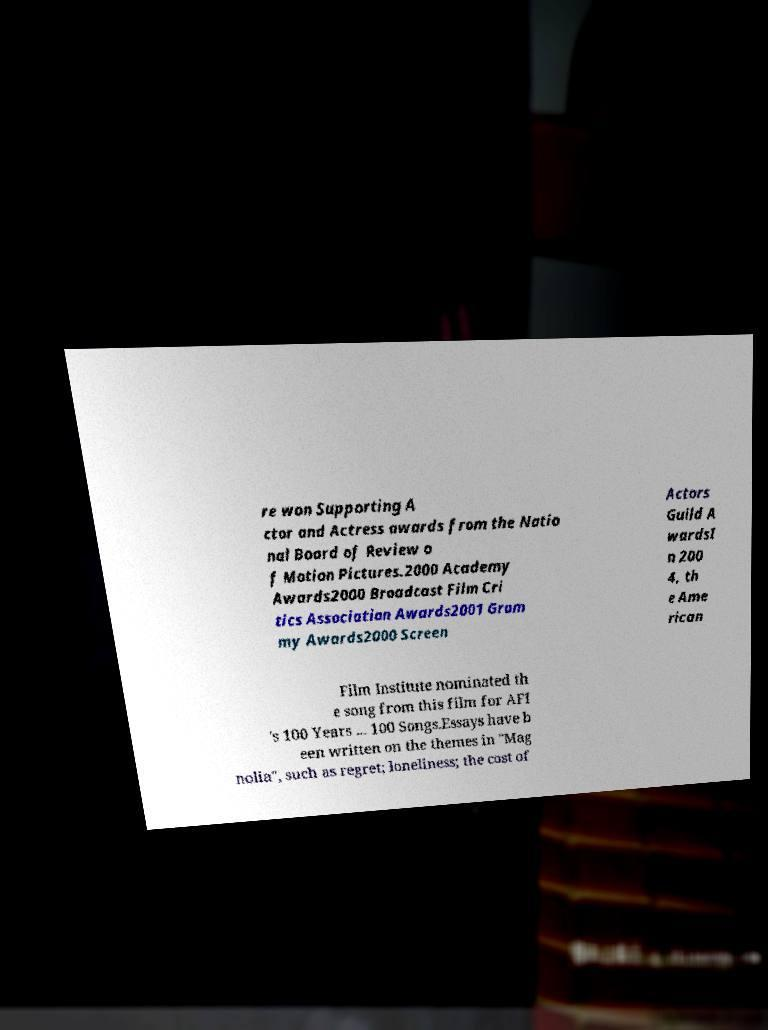Please identify and transcribe the text found in this image. re won Supporting A ctor and Actress awards from the Natio nal Board of Review o f Motion Pictures.2000 Academy Awards2000 Broadcast Film Cri tics Association Awards2001 Gram my Awards2000 Screen Actors Guild A wardsI n 200 4, th e Ame rican Film Institute nominated th e song from this film for AFI 's 100 Years ... 100 Songs.Essays have b een written on the themes in "Mag nolia", such as regret; loneliness; the cost of 